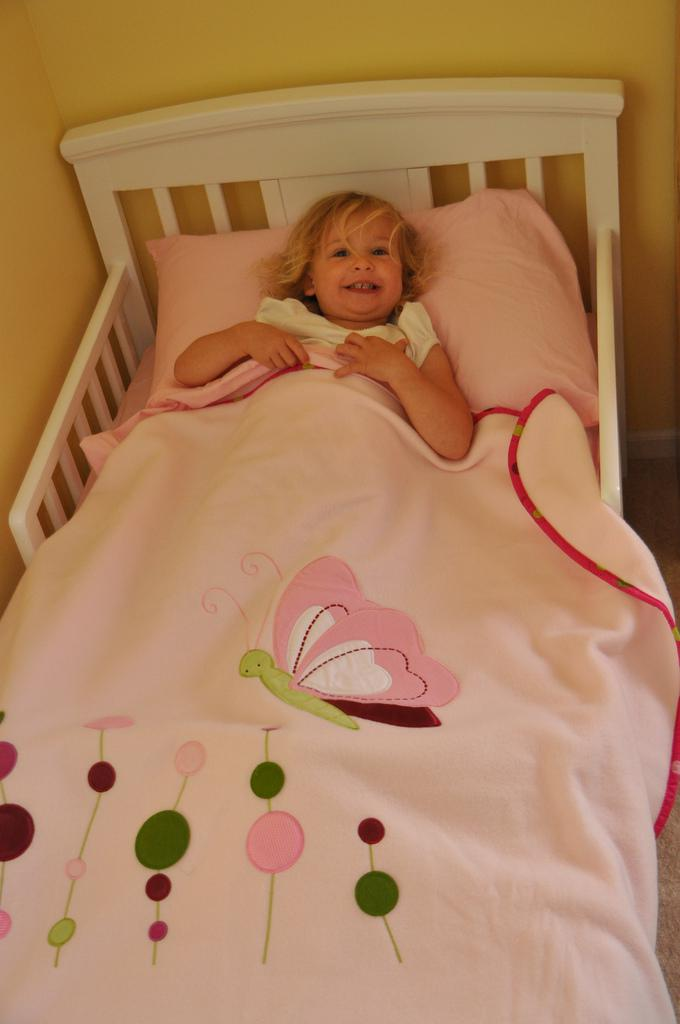Question: what color are the butterfly wings?
Choices:
A. Black and orange.
B. Yellow.
C. Red.
D. Pink.
Answer with the letter. Answer: D Question: when was this photo taken?
Choices:
A. At bedtime.
B. At night.
C. In the evening.
D. At 9om.
Answer with the letter. Answer: A Question: what is on the blanket?
Choices:
A. The children.
B. A pattern.
C. Bright colored circles.
D. Polygons.
Answer with the letter. Answer: C Question: what has rails and is the right size for the little girl?
Choices:
A. The mattress.
B. The bed.
C. The toddler bed.
D. The hospital bed.
Answer with the letter. Answer: C Question: where was the picture taken?
Choices:
A. Kitchen.
B. Bathroom.
C. Dining room.
D. In a toddler bedroom.
Answer with the letter. Answer: D Question: who is wide awake?
Choices:
A. The boy.
B. The cute girl.
C. The child.
D. The father.
Answer with the letter. Answer: B Question: who is in the bed?
Choices:
A. The dog.
B. A little girl.
C. The mom and dad.
D. My grandma.
Answer with the letter. Answer: B Question: where are the girls hands?
Choices:
A. Up in the air.
B. Over her chest.
C. On the basketball.
D. In the jar of money.
Answer with the letter. Answer: B Question: what color is the lining of the blanket?
Choices:
A. It is pink.
B. It is white.
C. It is blue.
D. It is green.
Answer with the letter. Answer: A Question: what is on her blanket?
Choices:
A. Flower.
B. A butterfly.
C. Clouds.
D. Grass.
Answer with the letter. Answer: B Question: who is in the photo?
Choices:
A. A woman.
B. A man.
C. A boy.
D. A little girl.
Answer with the letter. Answer: D Question: what color is the headboard?
Choices:
A. Green.
B. Grey.
C. White.
D. Brown.
Answer with the letter. Answer: C Question: what one item is multicolored?
Choices:
A. The umbrella.
B. The beach ball.
C. The pillow.
D. The blanket.
Answer with the letter. Answer: D 